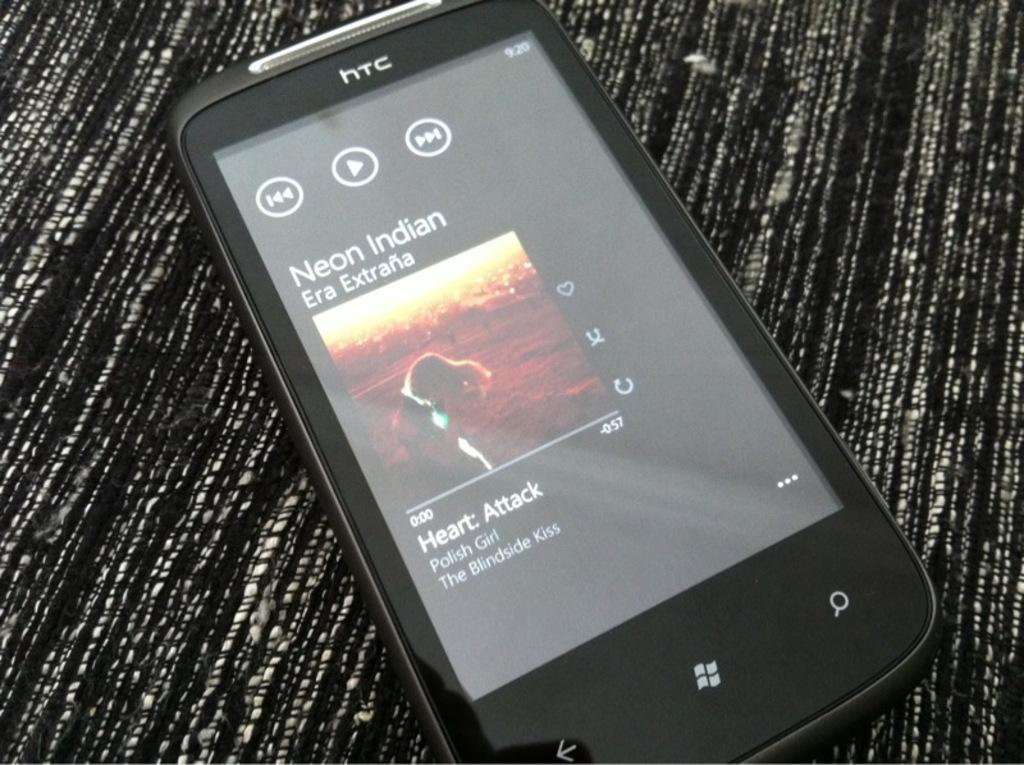<image>
Provide a brief description of the given image. A cell phone with Neon Indian playing on it. 